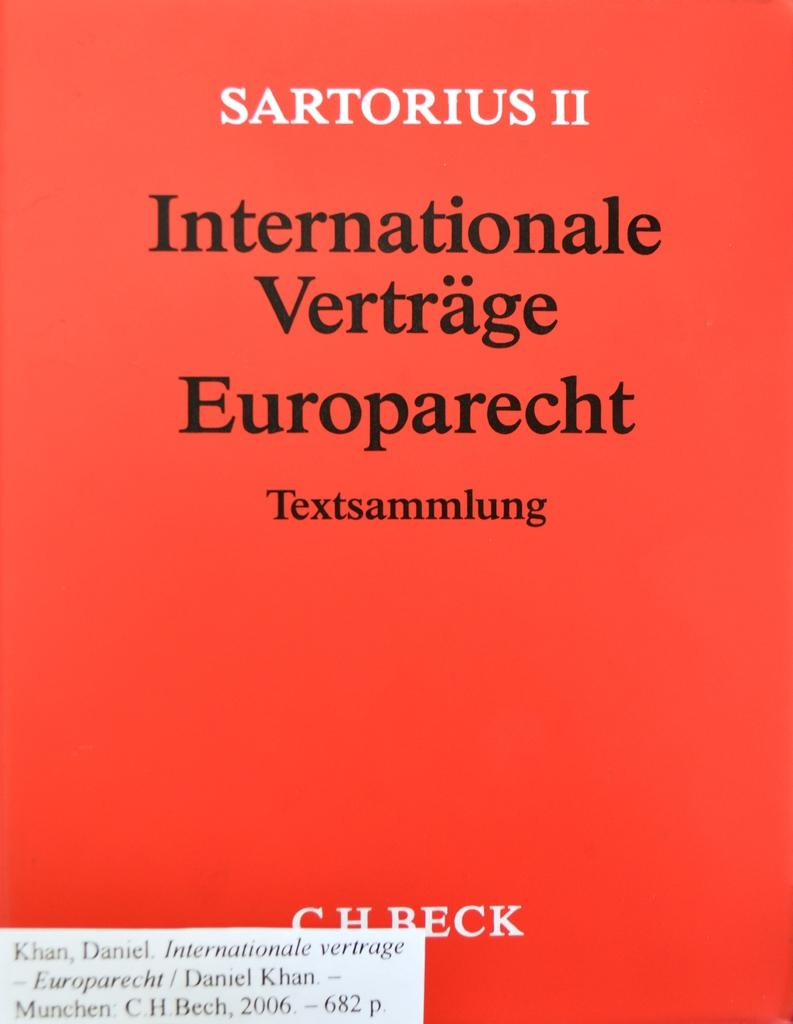<image>
Give a short and clear explanation of the subsequent image. A copy of the book Internationale Verträge Europarecht with a red cover. 